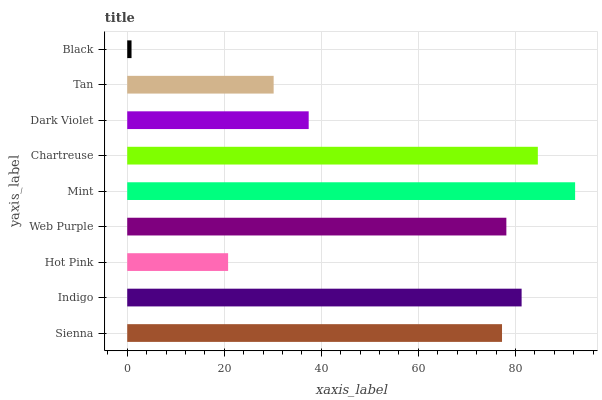Is Black the minimum?
Answer yes or no. Yes. Is Mint the maximum?
Answer yes or no. Yes. Is Indigo the minimum?
Answer yes or no. No. Is Indigo the maximum?
Answer yes or no. No. Is Indigo greater than Sienna?
Answer yes or no. Yes. Is Sienna less than Indigo?
Answer yes or no. Yes. Is Sienna greater than Indigo?
Answer yes or no. No. Is Indigo less than Sienna?
Answer yes or no. No. Is Sienna the high median?
Answer yes or no. Yes. Is Sienna the low median?
Answer yes or no. Yes. Is Dark Violet the high median?
Answer yes or no. No. Is Tan the low median?
Answer yes or no. No. 